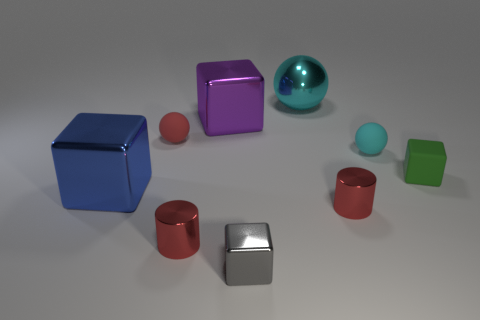Subtract 1 blocks. How many blocks are left? 3 Add 1 blue metal things. How many objects exist? 10 Subtract all cylinders. How many objects are left? 7 Subtract all big red cubes. Subtract all big metal objects. How many objects are left? 6 Add 7 red rubber spheres. How many red rubber spheres are left? 8 Add 9 gray metal things. How many gray metal things exist? 10 Subtract 0 cyan cylinders. How many objects are left? 9 